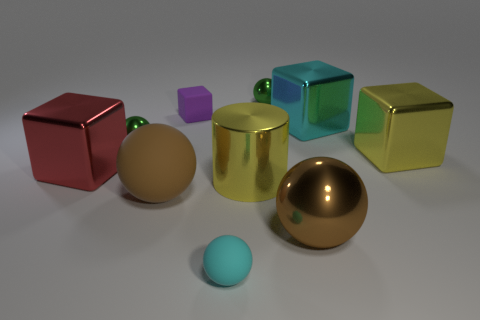Subtract all brown blocks. How many brown spheres are left? 2 Subtract all tiny matte blocks. How many blocks are left? 3 Subtract all brown spheres. How many spheres are left? 3 Subtract all cylinders. How many objects are left? 9 Subtract 2 blocks. How many blocks are left? 2 Subtract all large metallic things. Subtract all small green things. How many objects are left? 3 Add 2 small rubber spheres. How many small rubber spheres are left? 3 Add 7 brown metal things. How many brown metal things exist? 8 Subtract 1 purple blocks. How many objects are left? 9 Subtract all yellow cubes. Subtract all green cylinders. How many cubes are left? 3 